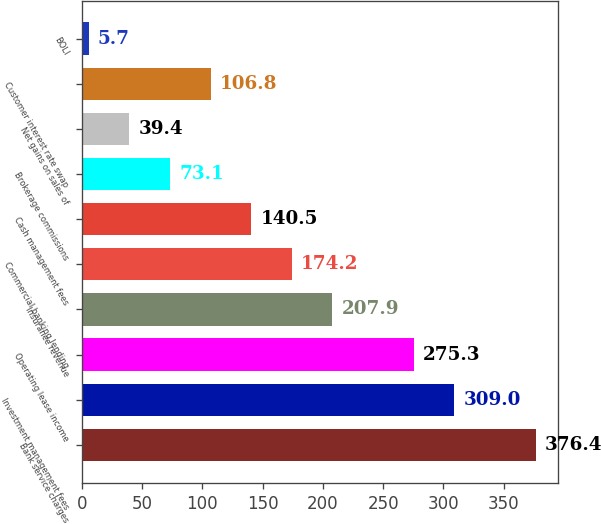Convert chart to OTSL. <chart><loc_0><loc_0><loc_500><loc_500><bar_chart><fcel>Bank service charges<fcel>Investment management fees<fcel>Operating lease income<fcel>Insurance revenue<fcel>Commercial banking lending<fcel>Cash management fees<fcel>Brokerage commissions<fcel>Net gains on sales of<fcel>Customer interest rate swap<fcel>BOLI<nl><fcel>376.4<fcel>309<fcel>275.3<fcel>207.9<fcel>174.2<fcel>140.5<fcel>73.1<fcel>39.4<fcel>106.8<fcel>5.7<nl></chart> 